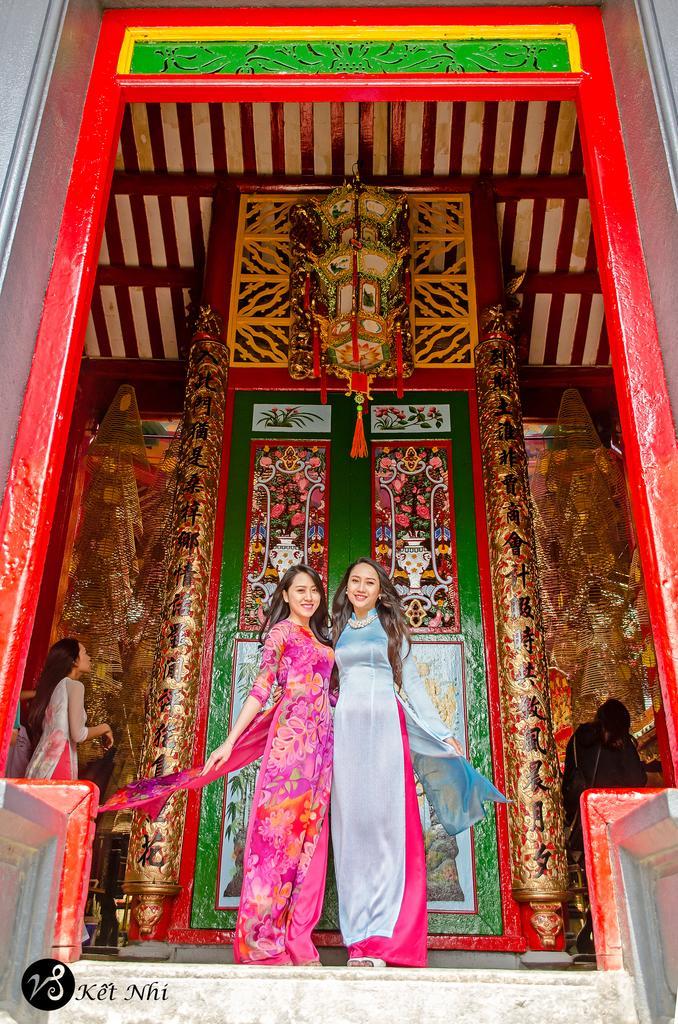In one or two sentences, can you explain what this image depicts? In the center of the image we can see women standing on the floor. In the background there is a door and building. 